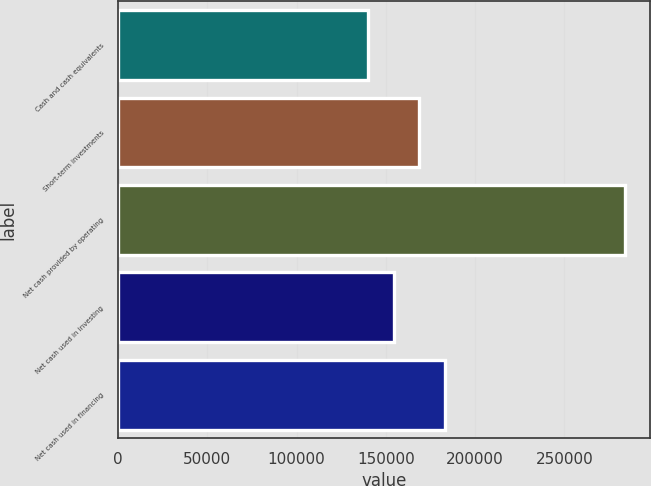Convert chart. <chart><loc_0><loc_0><loc_500><loc_500><bar_chart><fcel>Cash and cash equivalents<fcel>Short-term investments<fcel>Net cash provided by operating<fcel>Net cash used in investing<fcel>Net cash used in financing<nl><fcel>139881<fcel>168712<fcel>284037<fcel>154297<fcel>183128<nl></chart> 